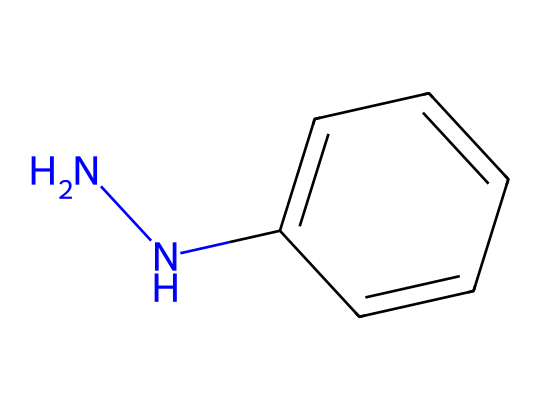What is the molecular formula of phenylhydrazine? The SMILES representation shows one nitrogen-nitrogen bond and a phenyl group (a benzene ring) attached to a nitrogen. By counting the atoms, the formula consists of six carbons, eight hydrogens, and two nitrogens. Thus, the molecular formula is C6H8N2.
Answer: C6H8N2 How many nitrogen atoms are present in phenylhydrazine? In the SMILES representation, there are two nitrogen atoms represented at the beginning of the structure, indicating that phenylhydrazine contains two nitrogen atoms.
Answer: 2 What type of bond is present between the nitrogen atoms in phenylhydrazine? The presence of the "NN" in the SMILES indicates a single bond between the two nitrogen atoms in phenylhydrazine, which is typical for hydrazines.
Answer: single bond Which functional group is indicated by the 'c' in the chemical structure? The lowercase 'c' represents a carbon atom that is part of an aromatic ring, specifically indicating that this compound has a phenyl group, which is the presence of a benzene ring.
Answer: phenyl group Why is phenylhydrazine used as a reducing agent? Phenylhydrazine contains NH groups that can donate electrons due to the presence of nitrogen's lone pair, making it effective in reducing metal surfaces by facilitating reduction reactions, particularly with metal ions.
Answer: NH groups How can the aromatic nature of phenylhydrazine influence its reducing properties? The phenyl group (c1ccccc1) is stabilized due to resonance, which enhances the stability of the molecule and helps maintain a favorable reaction pathway during reduction, making it a good reducing agent in treatments.
Answer: resonance stability 